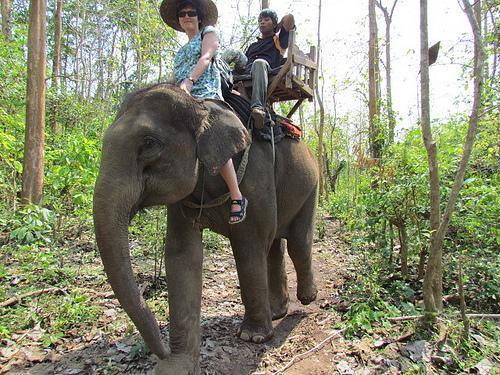How many elephants are there?
Give a very brief answer. 1. How many people are riding the elephant?
Give a very brief answer. 2. 